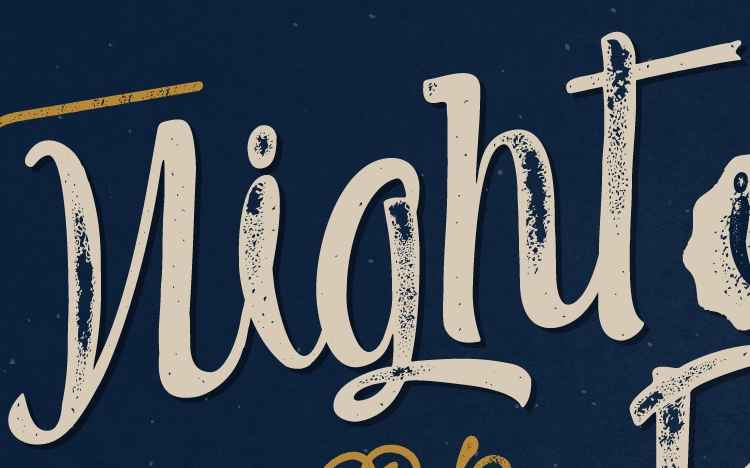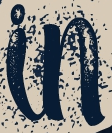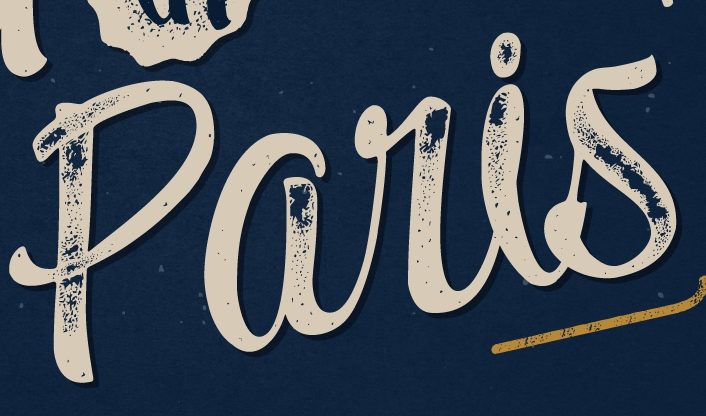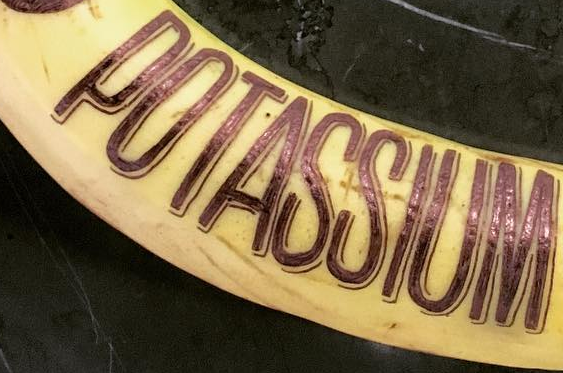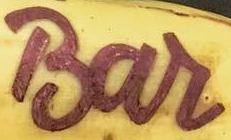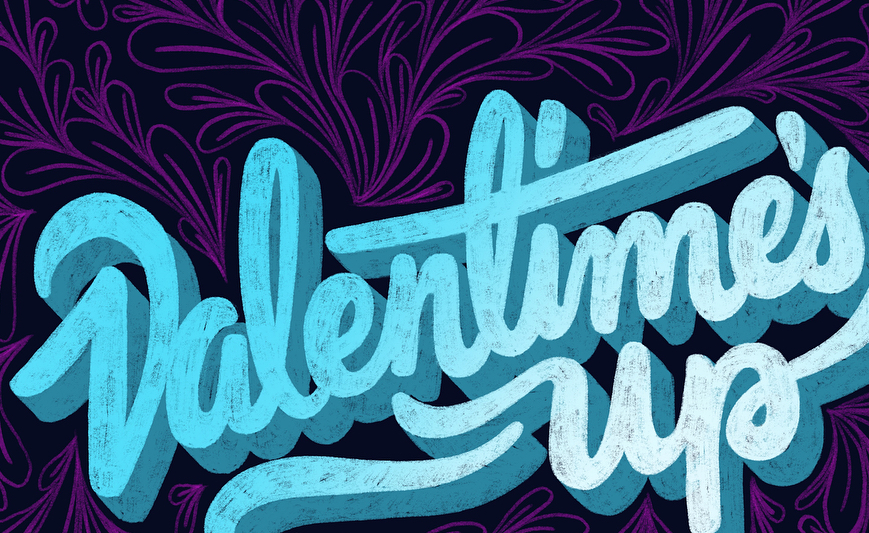Read the text from these images in sequence, separated by a semicolon. night; in; paris; POTASSIUM; Bar; Valentime's 